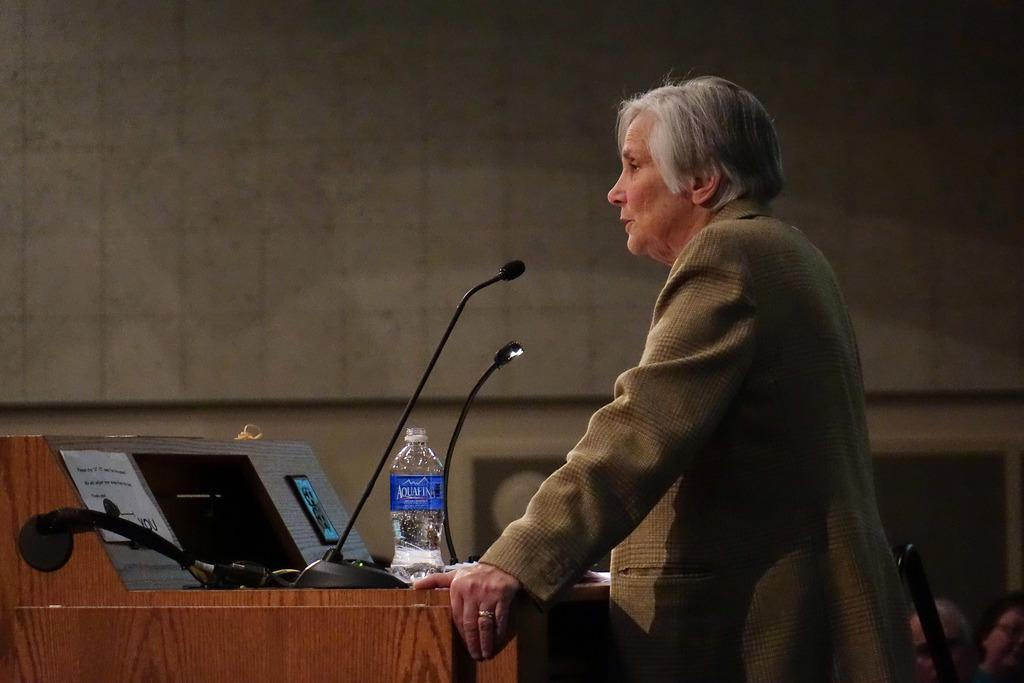What is the main subject in the foreground of the image? There is a person standing in the foreground of the image. What type of animals are present in the image? There are mice in the image. What is the bottle used for in the image? The bottle's purpose is not clear from the image, but it is present. What can be found on the desk in the image? There are other objects on a desk in the image. What is the shape of the harbor in the image? There is no harbor present in the image. What is the position of the person in relation to the mice in the image? The position of the person in relation to the mice cannot be determined from the image, as the exact location of the mice is not clear. 